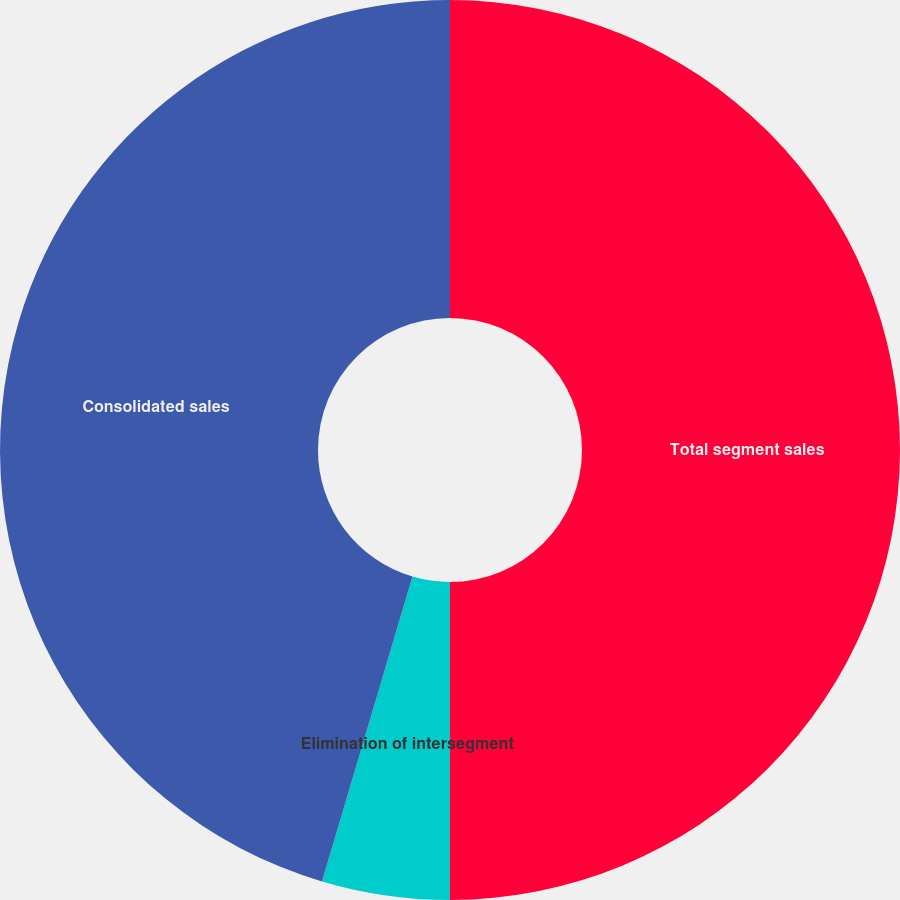Convert chart. <chart><loc_0><loc_0><loc_500><loc_500><pie_chart><fcel>Total segment sales<fcel>Elimination of intersegment<fcel>Corporate<fcel>Consolidated sales<nl><fcel>50.0%<fcel>4.59%<fcel>0.0%<fcel>45.41%<nl></chart> 